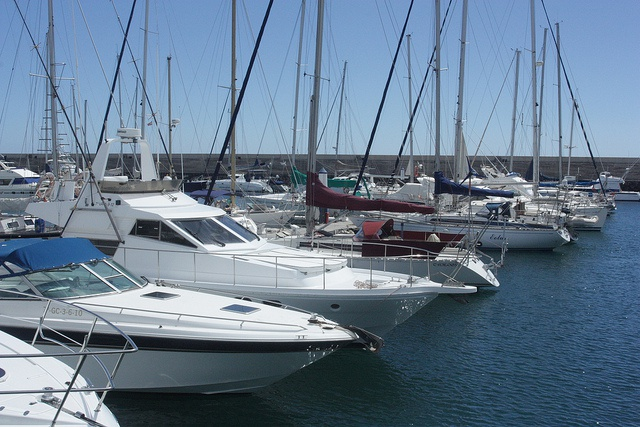Describe the objects in this image and their specific colors. I can see boat in gray, lightgray, black, and darkgray tones, boat in gray, darkgray, and lightgray tones, boat in gray, lightgray, darkgray, and black tones, boat in gray, black, darkgray, and blue tones, and boat in gray, black, darkgray, and blue tones in this image. 